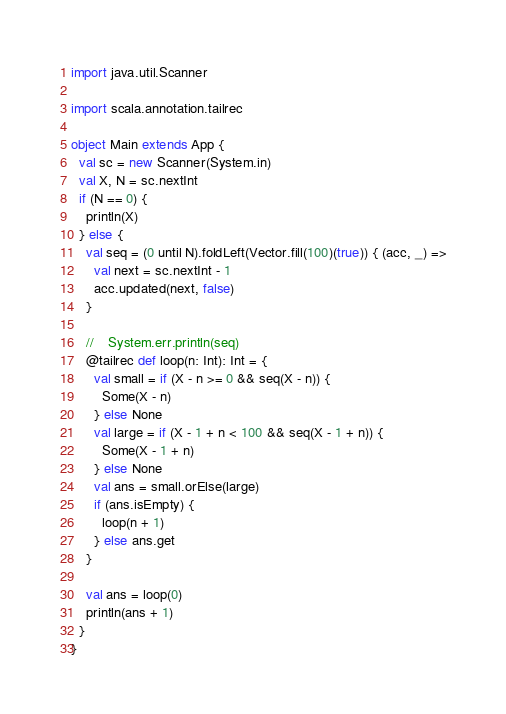Convert code to text. <code><loc_0><loc_0><loc_500><loc_500><_Scala_>import java.util.Scanner

import scala.annotation.tailrec

object Main extends App {
  val sc = new Scanner(System.in)
  val X, N = sc.nextInt
  if (N == 0) {
    println(X)
  } else {
    val seq = (0 until N).foldLeft(Vector.fill(100)(true)) { (acc, _) =>
      val next = sc.nextInt - 1
      acc.updated(next, false)
    }

    //    System.err.println(seq)
    @tailrec def loop(n: Int): Int = {
      val small = if (X - n >= 0 && seq(X - n)) {
        Some(X - n)
      } else None
      val large = if (X - 1 + n < 100 && seq(X - 1 + n)) {
        Some(X - 1 + n)
      } else None
      val ans = small.orElse(large)
      if (ans.isEmpty) {
        loop(n + 1)
      } else ans.get
    }

    val ans = loop(0)
    println(ans + 1)
  }
}
</code> 